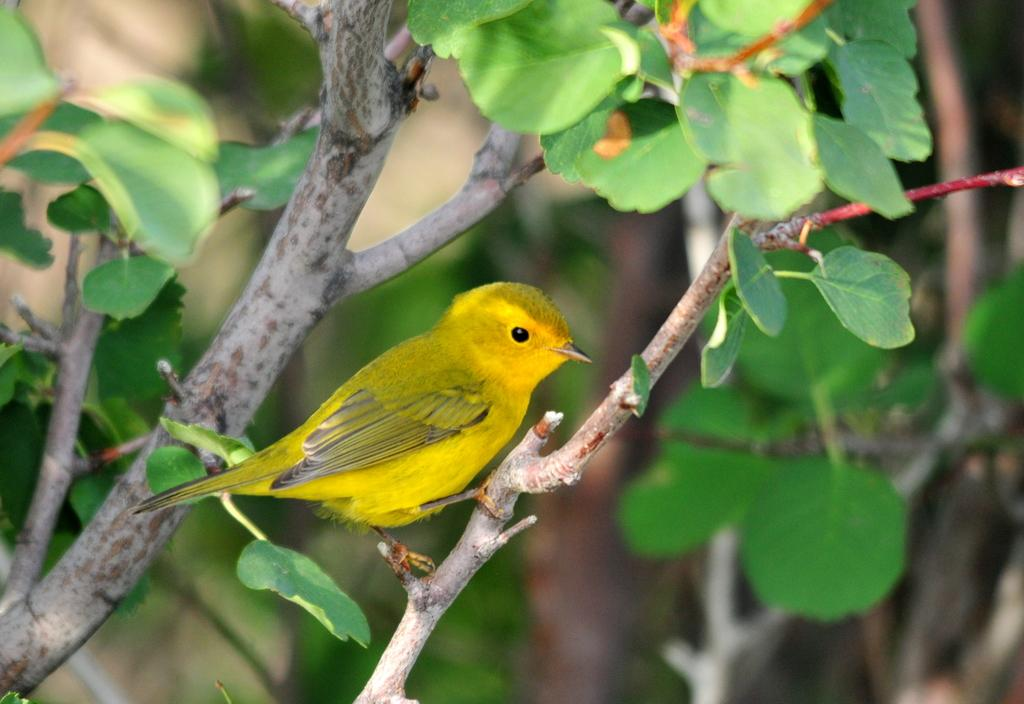What type of animal is in the image? There is a bird in the image. Where is the bird located? The bird is in a tree. Can you describe the background of the image? The background of the image is blurred. What type of shoes can be seen hanging from the branches of the tree in the image? There are no shoes present in the image; it features a bird in a tree with a blurred background. 